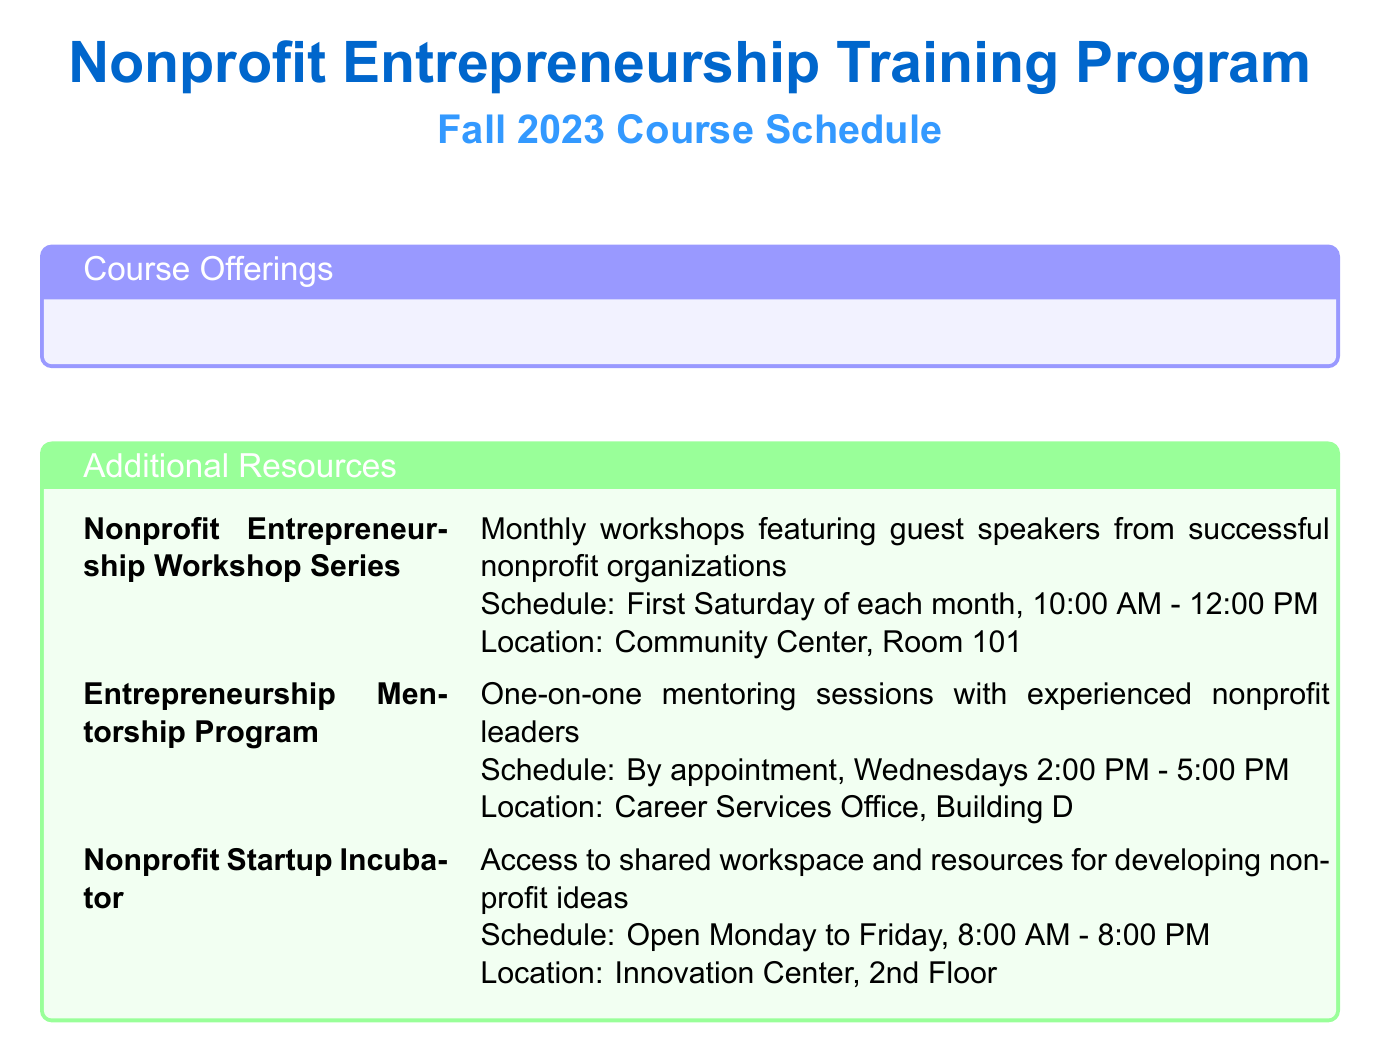What is the course code for Introduction to Social Entrepreneurship? The course code for Introduction to Social Entrepreneurship is listed as ENT 101.
Answer: ENT 101 Who teaches the course on Nonprofit Business Model Development? The instructor for Nonprofit Business Model Development is Prof. Michael Chen.
Answer: Prof. Michael Chen When does the Financial Management for Nonprofits course start? The course starts on September 7, 2023, as mentioned under its schedule.
Answer: September 7, 2023 What day is the Nonprofit Entrepreneurship Workshop Series scheduled? The schedule indicates that it takes place on the first Saturday of each month.
Answer: First Saturday of each month Which course ends on December 12, 2023? The Strategic Planning for Nonprofit Organizations course has its end date listed as December 12, 2023.
Answer: Strategic Planning for Nonprofit Organizations What time does the Legal and Ethical Issues in Nonprofit Management course start? The course starts at 6:00 PM on Mondays and Wednesdays, as stated in the document.
Answer: 6:00 PM How often do the Entrepreneurship Mentorship Program sessions occur? The document specifies that sessions are by appointment, which implies they do not occur on a set schedule but rather as needed.
Answer: By appointment What type of resource is the Nonprofit Startup Incubator? The document describes it as access to shared workspace and resources for developing nonprofit ideas.
Answer: Shared workspace and resources 